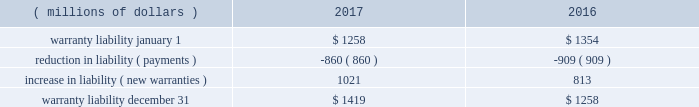2017 form 10-k | 115 and $ 1088 million , respectively , were primarily comprised of loans to dealers , and the spc 2019s liabilities of $ 1106 million and $ 1087 million , respectively , were primarily comprised of commercial paper .
The assets of the spc are not available to pay cat financial 2019s creditors .
Cat financial may be obligated to perform under the guarantee if the spc experiences losses .
No loss has been experienced or is anticipated under this loan purchase agreement .
Cat financial is party to agreements in the normal course of business with selected customers and caterpillar dealers in which they commit to provide a set dollar amount of financing on a pre- approved basis .
They also provide lines of credit to certain customers and caterpillar dealers , of which a portion remains unused as of the end of the period .
Commitments and lines of credit generally have fixed expiration dates or other termination clauses .
It has been cat financial 2019s experience that not all commitments and lines of credit will be used .
Management applies the same credit policies when making commitments and granting lines of credit as it does for any other financing .
Cat financial does not require collateral for these commitments/ lines , but if credit is extended , collateral may be required upon funding .
The amount of the unused commitments and lines of credit for dealers as of december 31 , 2017 and 2016 was $ 10993 million and $ 12775 million , respectively .
The amount of the unused commitments and lines of credit for customers as of december 31 , 2017 and 2016 was $ 3092 million and $ 3340 million , respectively .
Our product warranty liability is determined by applying historical claim rate experience to the current field population and dealer inventory .
Generally , historical claim rates are based on actual warranty experience for each product by machine model/engine size by customer or dealer location ( inside or outside north america ) .
Specific rates are developed for each product shipment month and are updated monthly based on actual warranty claim experience. .
22 .
Environmental and legal matters the company is regulated by federal , state and international environmental laws governing our use , transport and disposal of substances and control of emissions .
In addition to governing our manufacturing and other operations , these laws often impact the development of our products , including , but not limited to , required compliance with air emissions standards applicable to internal combustion engines .
We have made , and will continue to make , significant research and development and capital expenditures to comply with these emissions standards .
We are engaged in remedial activities at a number of locations , often with other companies , pursuant to federal and state laws .
When it is probable we will pay remedial costs at a site , and those costs can be reasonably estimated , the investigation , remediation , and operating and maintenance costs are accrued against our earnings .
Costs are accrued based on consideration of currently available data and information with respect to each individual site , including available technologies , current applicable laws and regulations , and prior remediation experience .
Where no amount within a range of estimates is more likely , we accrue the minimum .
Where multiple potentially responsible parties are involved , we consider our proportionate share of the probable costs .
In formulating the estimate of probable costs , we do not consider amounts expected to be recovered from insurance companies or others .
We reassess these accrued amounts on a quarterly basis .
The amount recorded for environmental remediation is not material and is included in accrued expenses .
We believe there is no more than a remote chance that a material amount for remedial activities at any individual site , or at all the sites in the aggregate , will be required .
On january 7 , 2015 , the company received a grand jury subpoena from the u.s .
District court for the central district of illinois .
The subpoena requests documents and information from the company relating to , among other things , financial information concerning u.s .
And non-u.s .
Caterpillar subsidiaries ( including undistributed profits of non-u.s .
Subsidiaries and the movement of cash among u.s .
And non-u.s .
Subsidiaries ) .
The company has received additional subpoenas relating to this investigation requesting additional documents and information relating to , among other things , the purchase and resale of replacement parts by caterpillar inc .
And non-u.s .
Caterpillar subsidiaries , dividend distributions of certain non-u.s .
Caterpillar subsidiaries , and caterpillar sarl and related structures .
On march 2-3 , 2017 , agents with the department of commerce , the federal deposit insurance corporation and the internal revenue service executed search and seizure warrants at three facilities of the company in the peoria , illinois area , including its former corporate headquarters .
The warrants identify , and agents seized , documents and information related to , among other things , the export of products from the united states , the movement of products between the united states and switzerland , the relationship between caterpillar inc .
And caterpillar sarl , and sales outside the united states .
It is the company 2019s understanding that the warrants , which concern both tax and export activities , are related to the ongoing grand jury investigation .
The company is continuing to cooperate with this investigation .
The company is unable to predict the outcome or reasonably estimate any potential loss ; however , we currently believe that this matter will not have a material adverse effect on the company 2019s consolidated results of operations , financial position or liquidity .
On march 20 , 2014 , brazil 2019s administrative council for economic defense ( cade ) published a technical opinion which named 18 companies and over 100 individuals as defendants , including two subsidiaries of caterpillar inc. , mge - equipamentos e servi e7os ferrovi e1rios ltda .
( mge ) and caterpillar brasil ltda .
The publication of the technical opinion opened cade 2019s official administrative investigation into allegations that the defendants participated in anticompetitive bid activity for the construction and maintenance of metro and train networks in brazil .
While companies cannot be .
What is the net change in warranty liability during 2017? 
Computations: (1419 - 1258)
Answer: 161.0. 